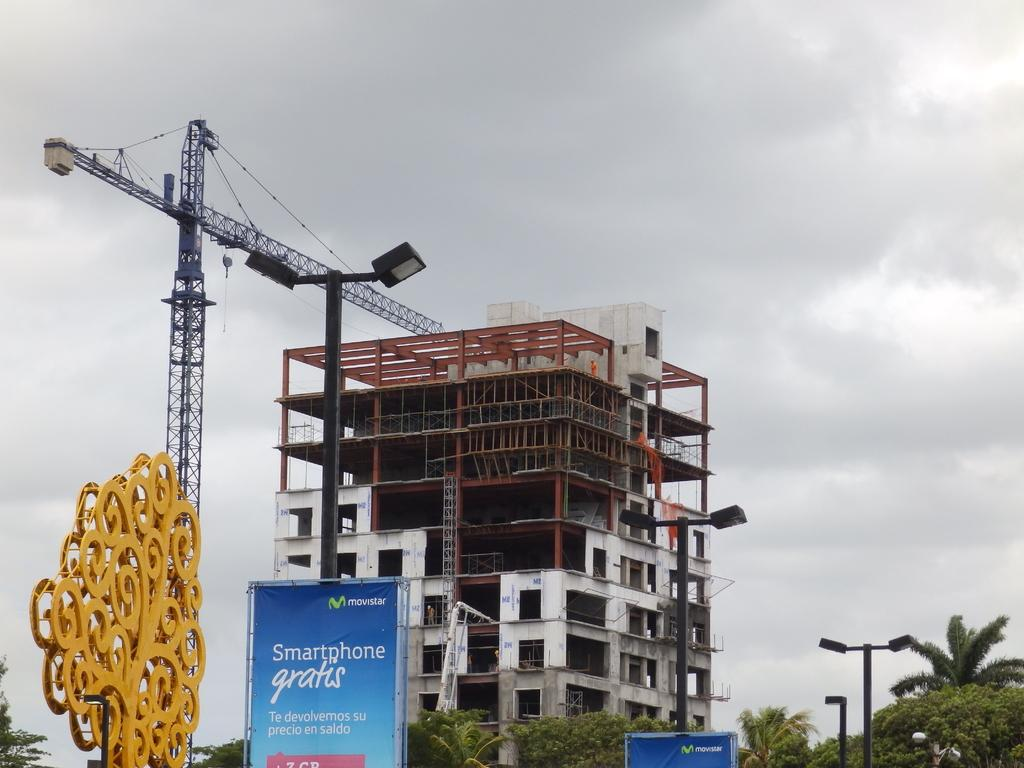What type of structure is present in the image? There is a building in the image. What other objects can be seen in the image? There are poles, lights, boards, a crane, and trees in the image. What is the purpose of the poles and lights in the image? The poles and lights may be used for illumination or signage. What is the crane used for in the image? The crane is likely used for construction or lifting heavy objects. What can be seen in the background of the image? The sky is visible in the background of the image. What type of bread is being used to create friction between the poles in the image? There is no bread or friction between poles present in the image. What event is taking place in the image that is related to birth? There is no event related to birth depicted in the image. 